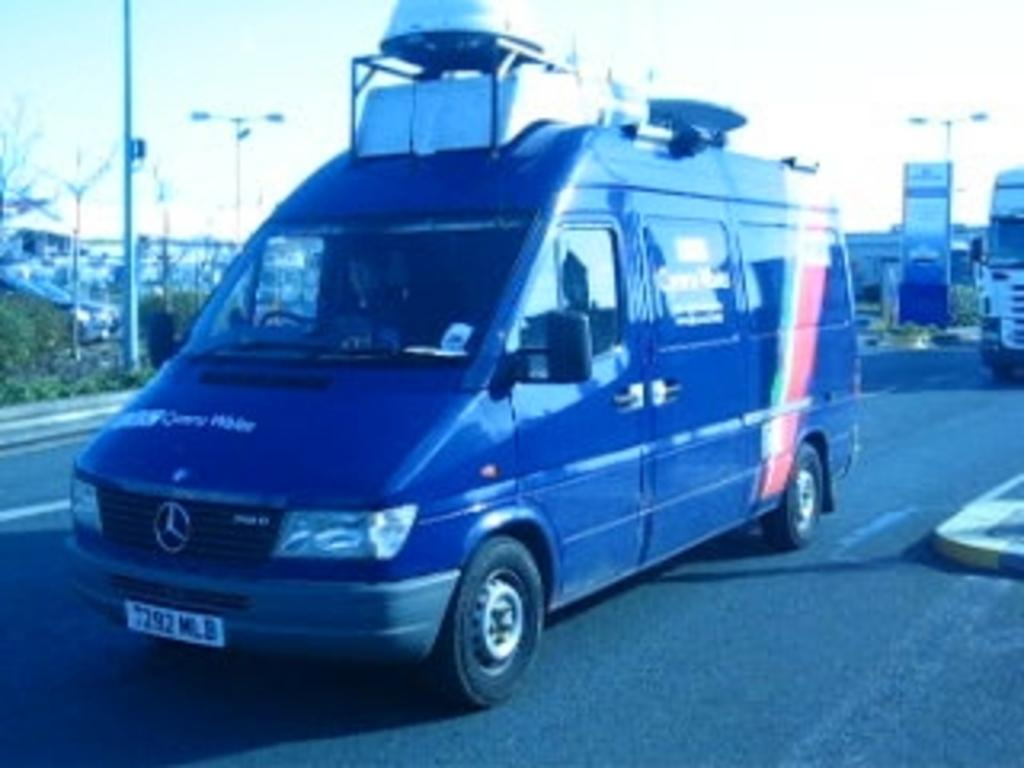Provide a one-sentence caption for the provided image. a mercedex van with cargo room on the top. 